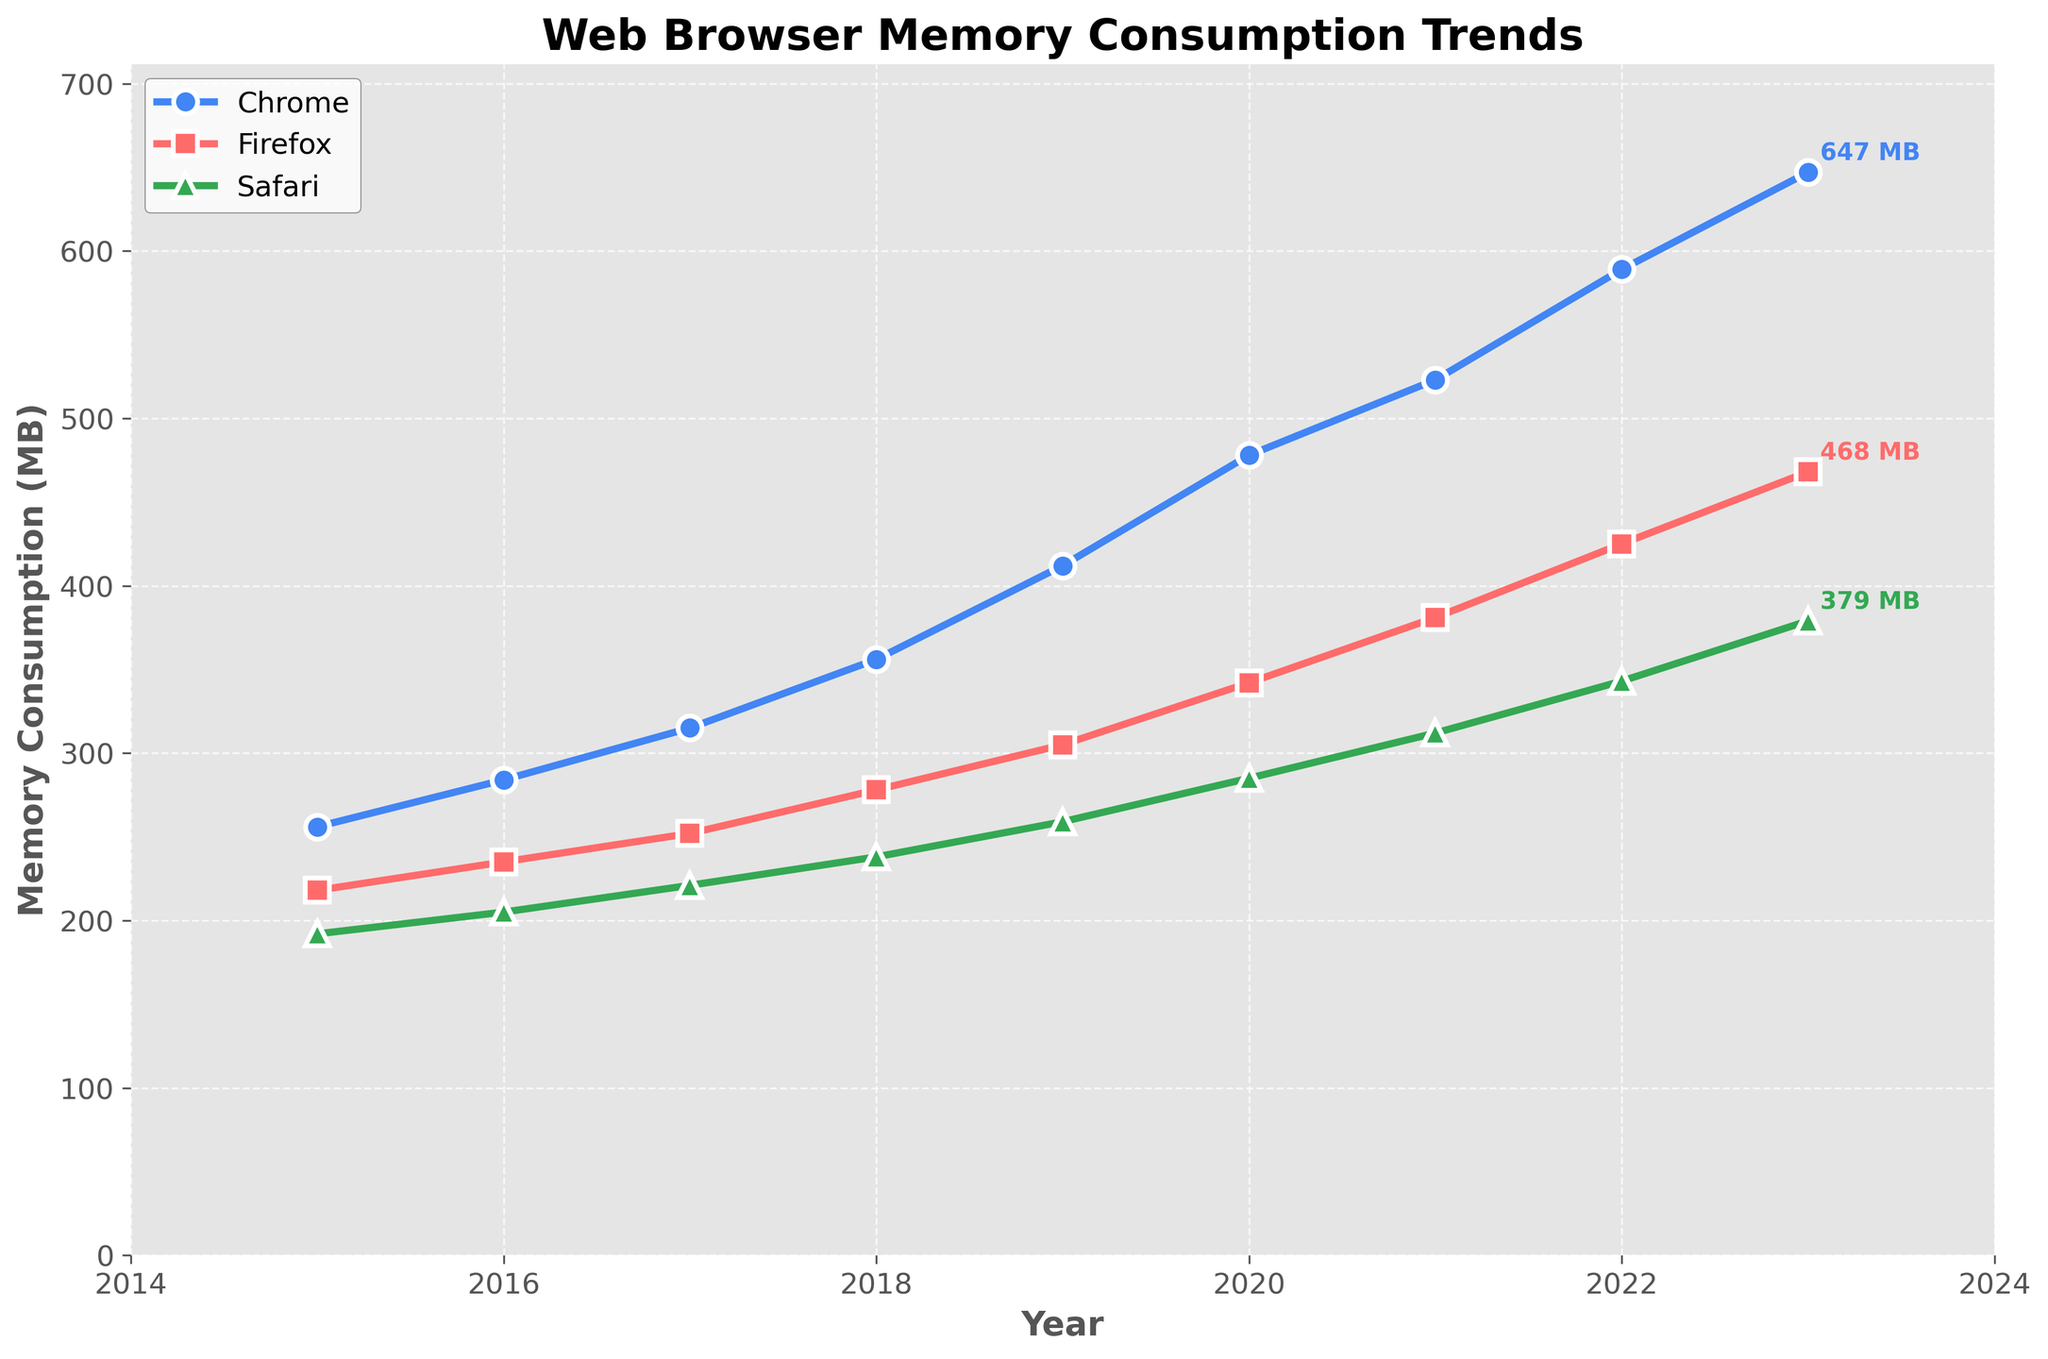What is the trend in Chrome's memory consumption from 2015 to 2023? The figure shows an upward trend for Chrome's memory consumption over the years 2015 to 2023. Each year, Chrome's memory usage is higher than the previous year.
Answer: Upward trend Which browser had the highest memory consumption in 2019? In 2019, Chrome's memory consumption is the highest among the three browsers, surpassing both Firefox and Safari.
Answer: Chrome Which year marks the biggest difference in memory consumption between Chrome and Safari? Comparing the differences between Chrome and Safari for each year, 2023 shows the biggest difference. In 2023, Chrome uses 647 MB while Safari uses 379 MB, leading to a difference of 268 MB.
Answer: 2023 How does the memory consumption of Firefox in 2022 compare to its consumption in 2015? In 2022, Firefox's memory consumption is 425 MB, while in 2015 it was 218 MB. This shows that Firefox’s memory consumption has nearly doubled over this period.
Answer: Nearly doubled By how much has Safari's memory consumption increased from 2016 to 2023? In 2016, Safari's memory consumption was 205 MB, and in 2023 it is 379 MB. The increase is 379 - 205 = 174 MB.
Answer: 174 MB Which browser showed the most consistent increase in memory usage over the period from 2015 to 2023? Examining the lines for each browser, Safari shows the most linear and consistent increase in memory usage without any large spikes or drops.
Answer: Safari At the end of the recorded period, which browser shows the highest rate of increase in memory consumption? The steepest line at the end of the period, indicating the highest rate of increase, is for Chrome. The slope of Chrome's line increases more than those of Firefox and Safari.
Answer: Chrome What is the average memory consumption of Firefox from 2018 to 2023? To find the average, add Firefox's memory consumption from 2018 to 2023 (278 + 305 + 342 + 381 + 425 + 468) which equals 2199 MB. Divide by the number of years (6), resulting in an average of 2199 / 6 = 366.5 MB.
Answer: 366.5 MB How does the memory consumption of the three browsers in 2020 rank from highest to lowest? In 2020, Chrome's memory consumption is 478 MB, Firefox's is 342 MB, and Safari's is 285 MB, ranking them as Chrome > Firefox > Safari.
Answer: Chrome > Firefox > Safari 